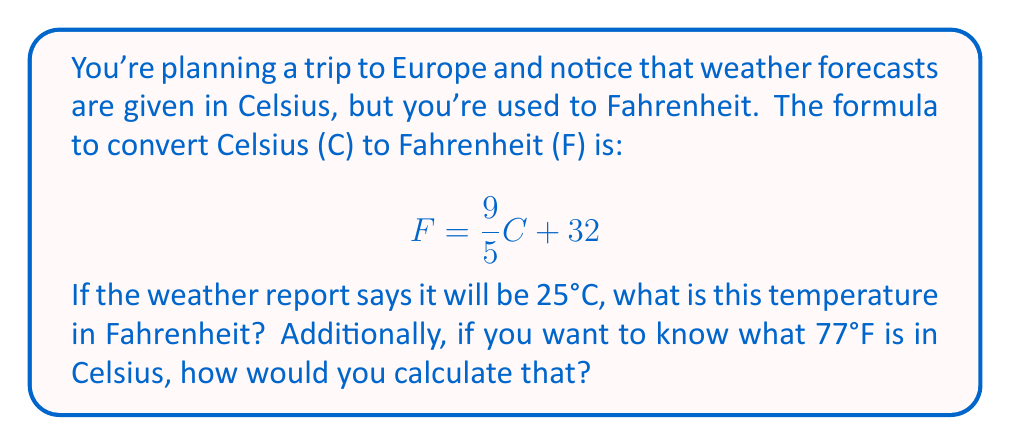Teach me how to tackle this problem. Let's approach this step-by-step:

1) First, let's convert 25°C to Fahrenheit using the given formula:

   $$F = \frac{9}{5}C + 32$$
   $$F = \frac{9}{5}(25) + 32$$
   $$F = 45 + 32 = 77°F$$

2) Now, to convert 77°F to Celsius, we need to use the inverse function. To find the inverse function, we can:
   a) Replace F with y and C with x
   b) Swap x and y
   c) Solve for y

   Starting with: $$y = \frac{9}{5}x + 32$$
   
   Swapping x and y: $$x = \frac{9}{5}y + 32$$
   
   Subtracting 32 from both sides: $$x - 32 = \frac{9}{5}y$$
   
   Multiplying both sides by $\frac{5}{9}$: $$\frac{5}{9}(x - 32) = y$$

3) This gives us the inverse function, which converts Fahrenheit to Celsius:

   $$C = \frac{5}{9}(F - 32)$$

4) Now we can use this to convert 77°F to Celsius:

   $$C = \frac{5}{9}(77 - 32)$$
   $$C = \frac{5}{9}(45)$$
   $$C = 25°C$$

This confirms that our inverse function works correctly, as it gives us back our original Celsius temperature.
Answer: 25°C = 77°F; 77°F = 25°C 